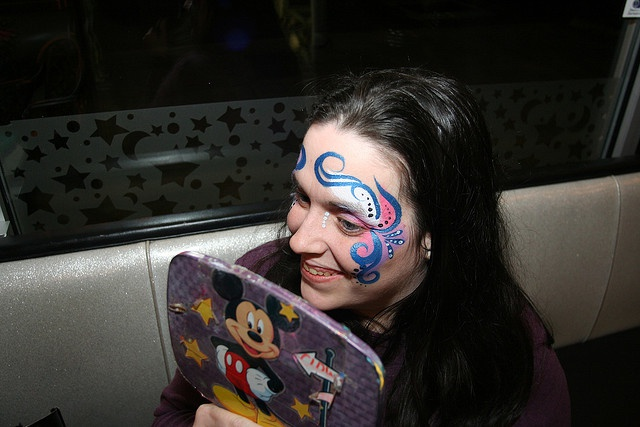Describe the objects in this image and their specific colors. I can see people in black, gray, and maroon tones and couch in black, gray, and darkgray tones in this image. 